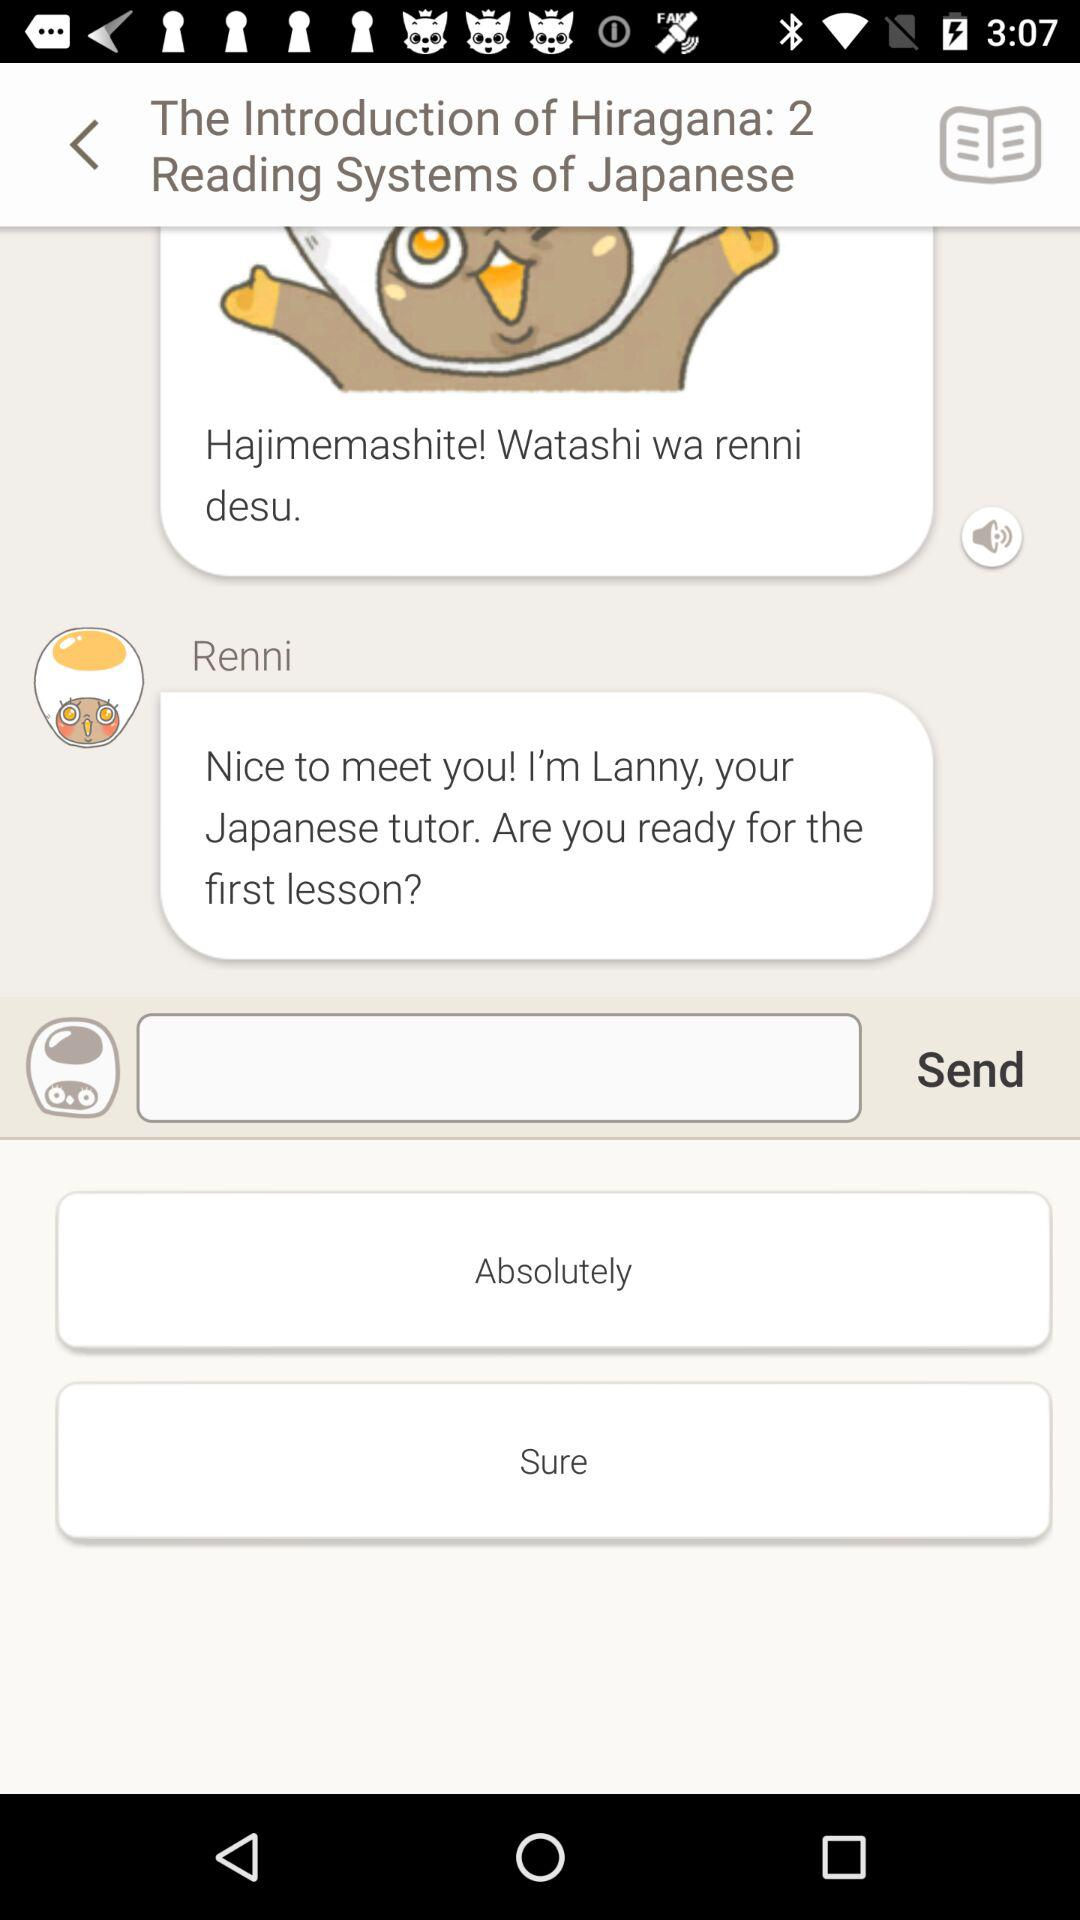What's the Introduction of Hiragana number?
When the provided information is insufficient, respond with <no answer>. <no answer> 